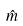<formula> <loc_0><loc_0><loc_500><loc_500>\hat { m }</formula> 